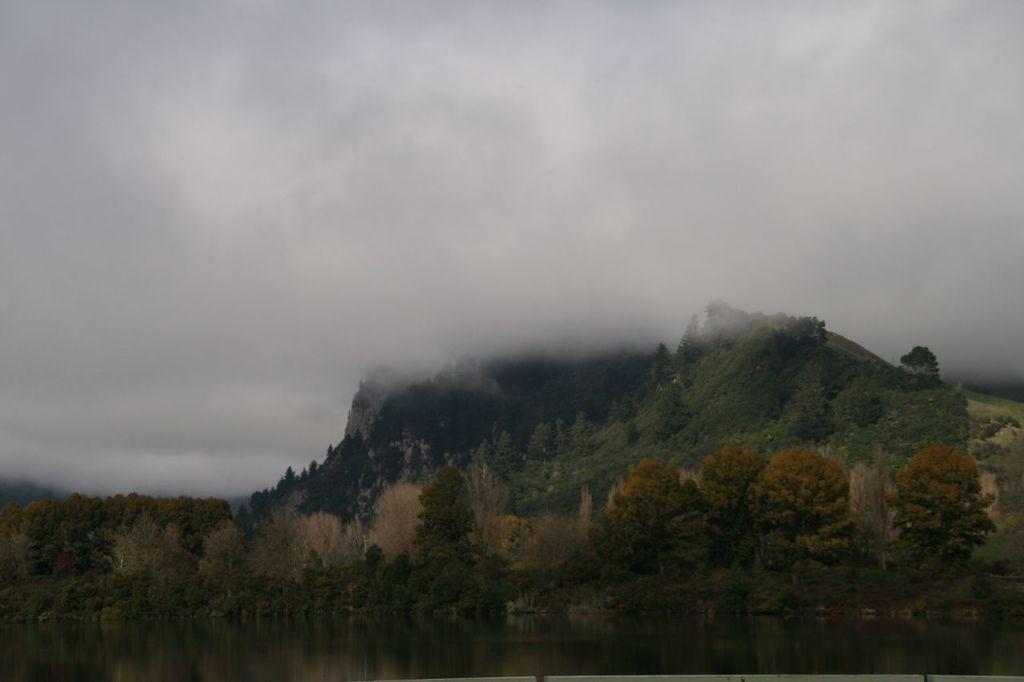In one or two sentences, can you explain what this image depicts? In this image there are water, trees, mountains and the sky. 